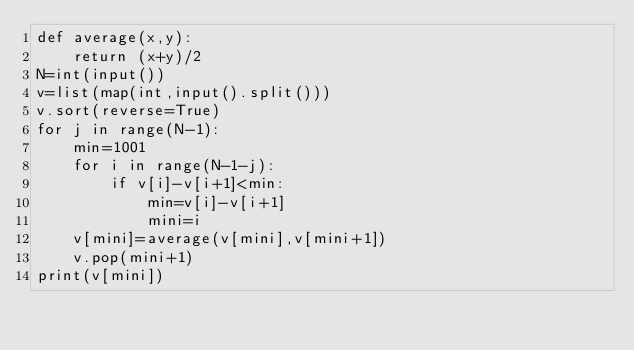Convert code to text. <code><loc_0><loc_0><loc_500><loc_500><_Python_>def average(x,y):
    return (x+y)/2
N=int(input())
v=list(map(int,input().split()))
v.sort(reverse=True)
for j in range(N-1):
    min=1001
    for i in range(N-1-j):
        if v[i]-v[i+1]<min:
            min=v[i]-v[i+1]
            mini=i
    v[mini]=average(v[mini],v[mini+1])
    v.pop(mini+1)
print(v[mini])</code> 